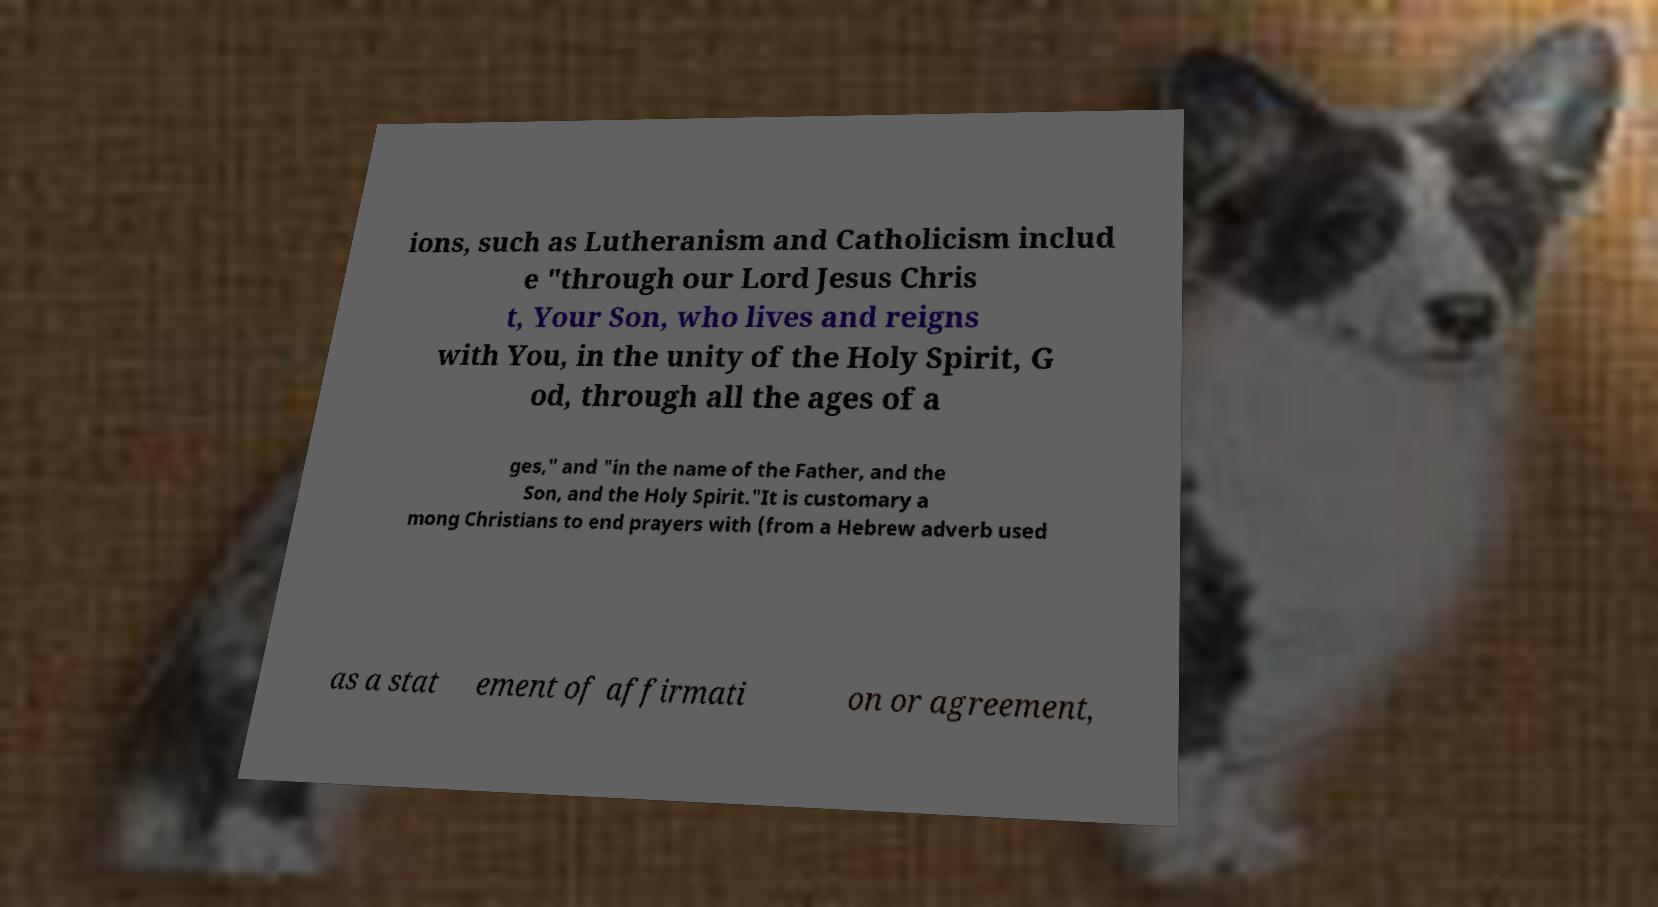Can you accurately transcribe the text from the provided image for me? ions, such as Lutheranism and Catholicism includ e "through our Lord Jesus Chris t, Your Son, who lives and reigns with You, in the unity of the Holy Spirit, G od, through all the ages of a ges," and "in the name of the Father, and the Son, and the Holy Spirit."It is customary a mong Christians to end prayers with (from a Hebrew adverb used as a stat ement of affirmati on or agreement, 